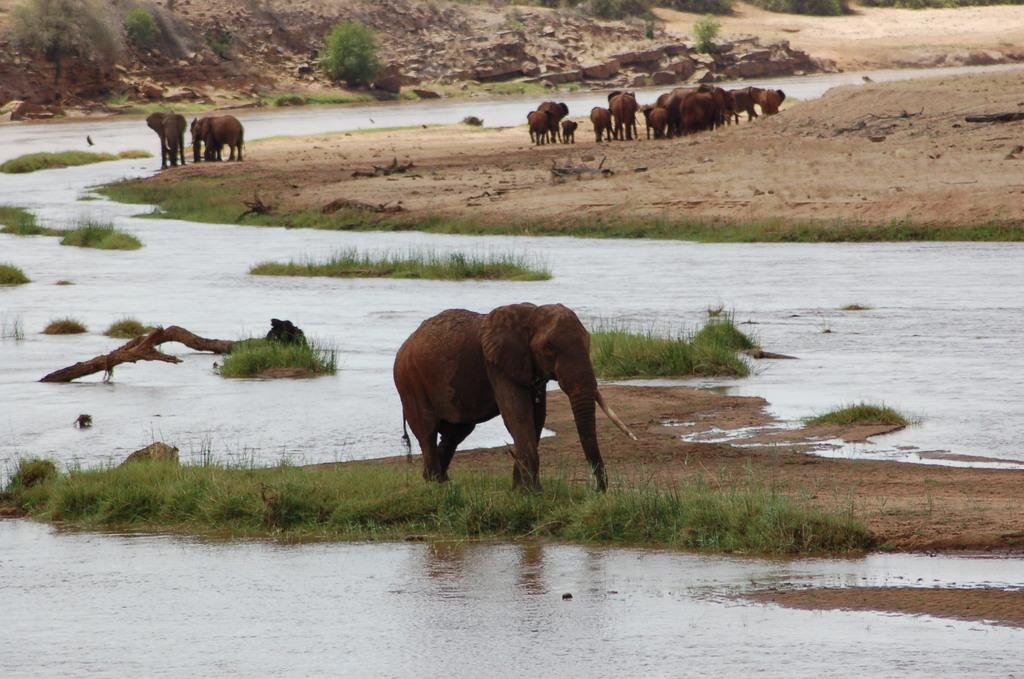What animal is the main subject of the image? There is an elephant in the image. What is the elephant doing in the image? The elephant is walking on grass in the image. What else can be seen in the image besides the elephant? There is water visible in the image. What can be seen in the background of the image? There are other elephants, animals, and plants in the background of the image. What type of chalk is the elephant holding in the image? There is no chalk present in the image; the elephant is walking on grass and there are no objects in its trunk. 